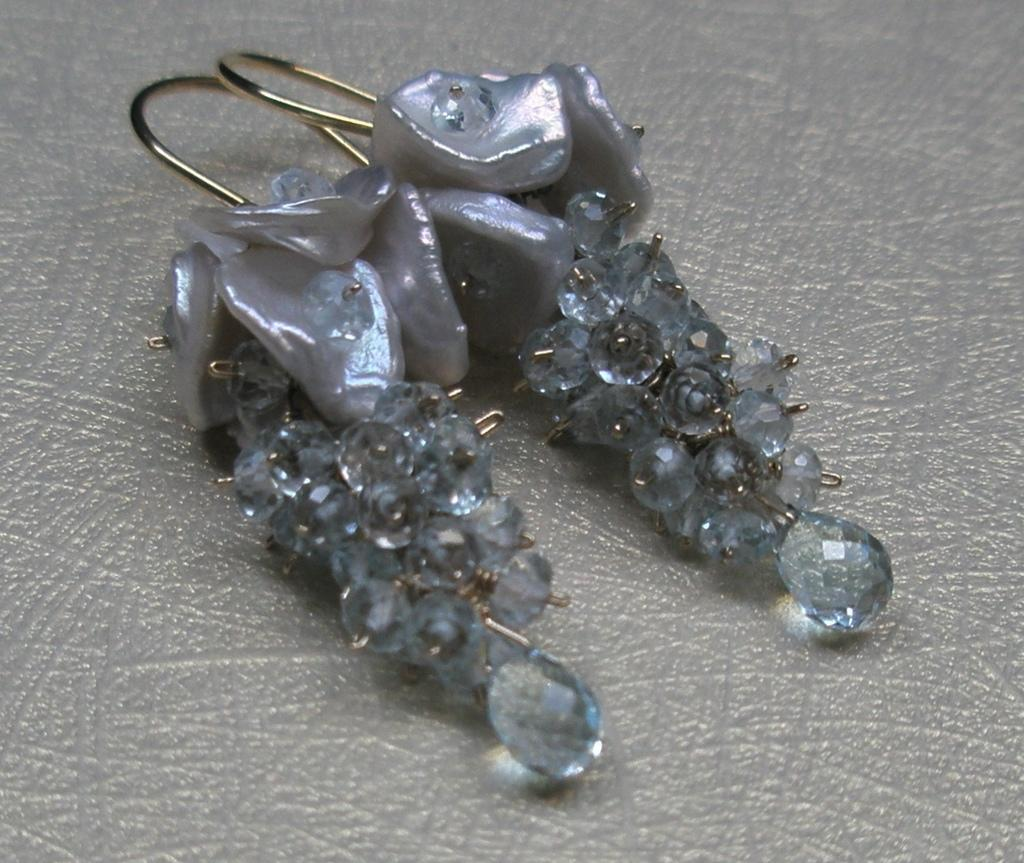What type of accessory is present in the image? There are earrings in the image. What color are the earrings? The earrings are in ash color. What is the color of the surface on which the earrings are placed? The earrings are on an ash color surface. How many bikes are parked next to the earrings in the image? There are no bikes present in the image; it only features earrings on an ash color surface. 